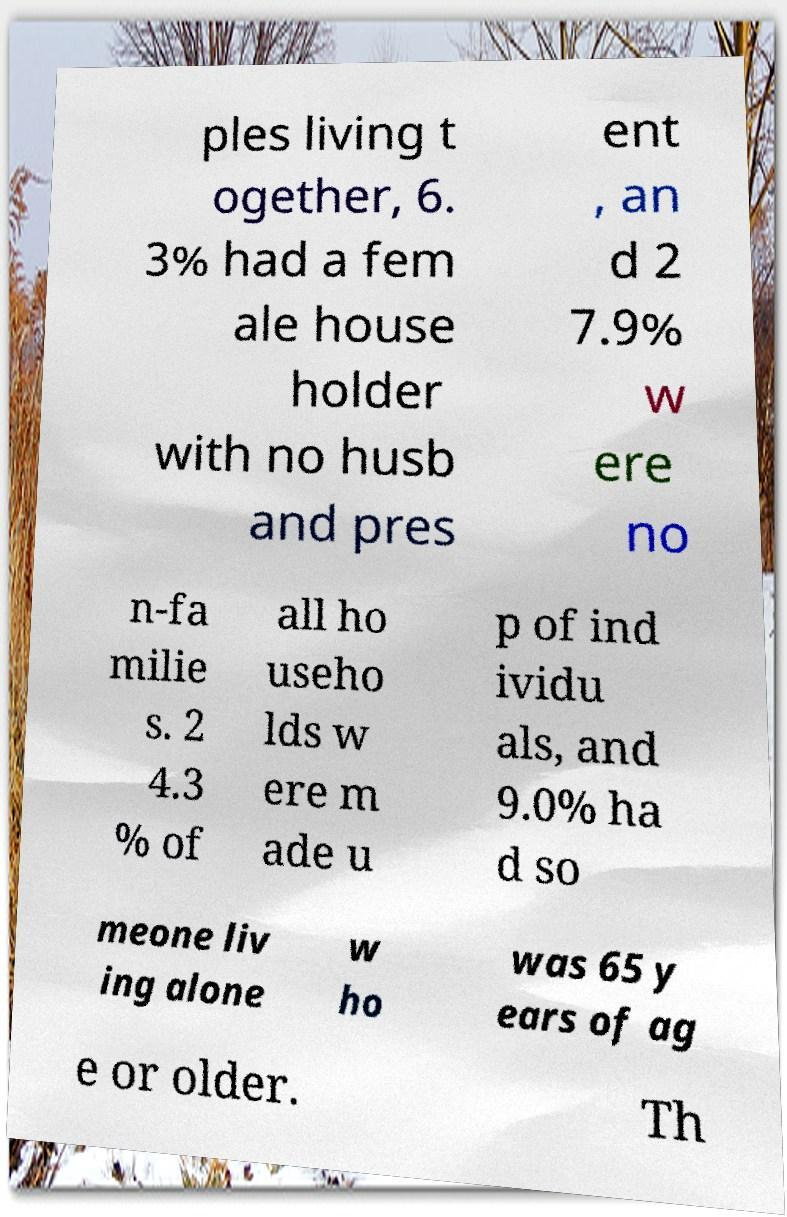There's text embedded in this image that I need extracted. Can you transcribe it verbatim? ples living t ogether, 6. 3% had a fem ale house holder with no husb and pres ent , an d 2 7.9% w ere no n-fa milie s. 2 4.3 % of all ho useho lds w ere m ade u p of ind ividu als, and 9.0% ha d so meone liv ing alone w ho was 65 y ears of ag e or older. Th 